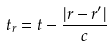Convert formula to latex. <formula><loc_0><loc_0><loc_500><loc_500>t _ { r } = t - \frac { | r - r ^ { \prime } | } { c }</formula> 